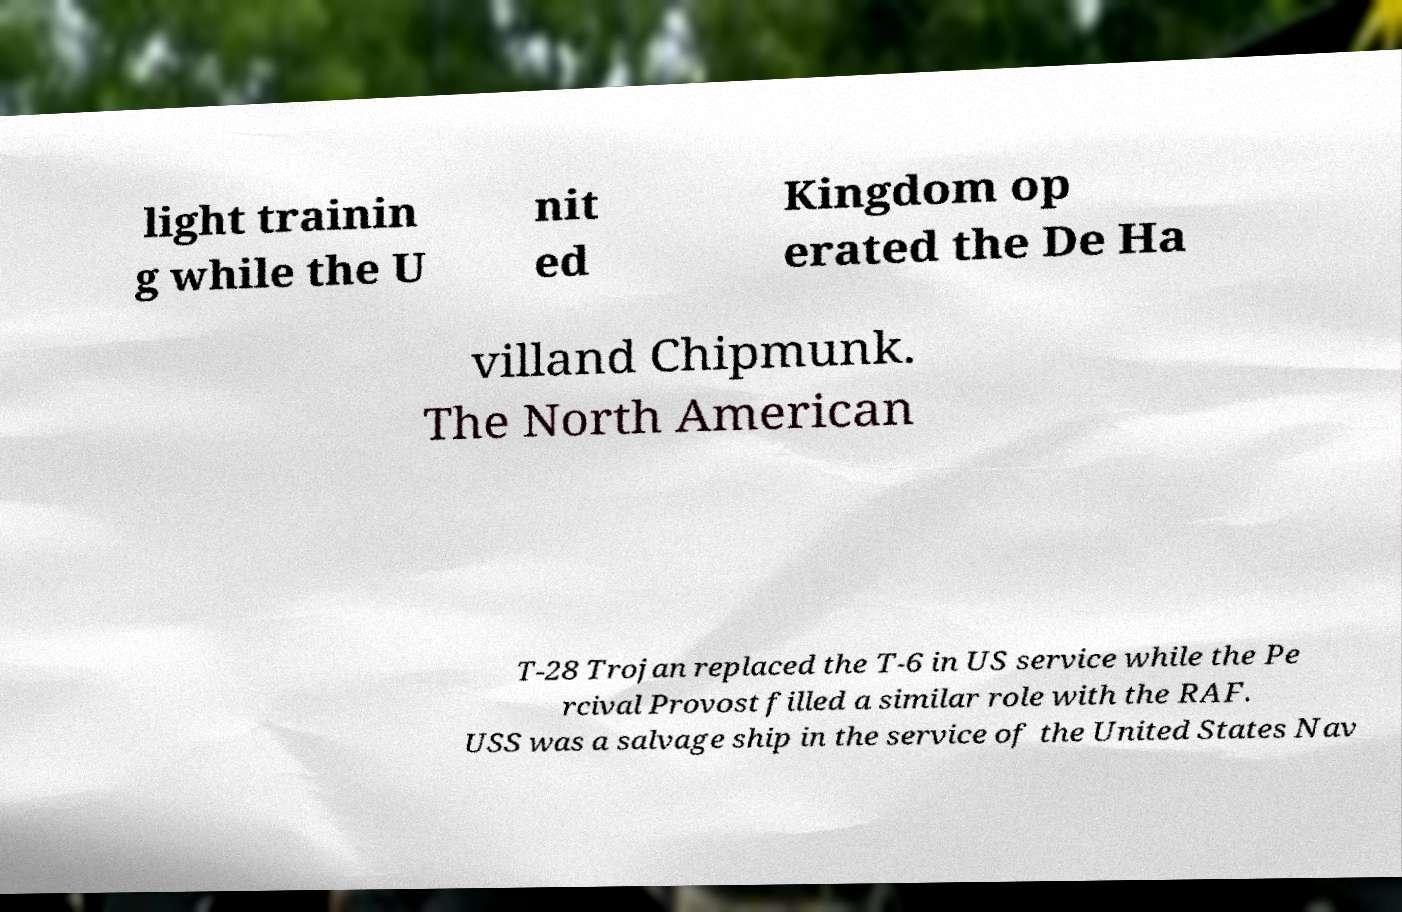Can you accurately transcribe the text from the provided image for me? light trainin g while the U nit ed Kingdom op erated the De Ha villand Chipmunk. The North American T-28 Trojan replaced the T-6 in US service while the Pe rcival Provost filled a similar role with the RAF. USS was a salvage ship in the service of the United States Nav 